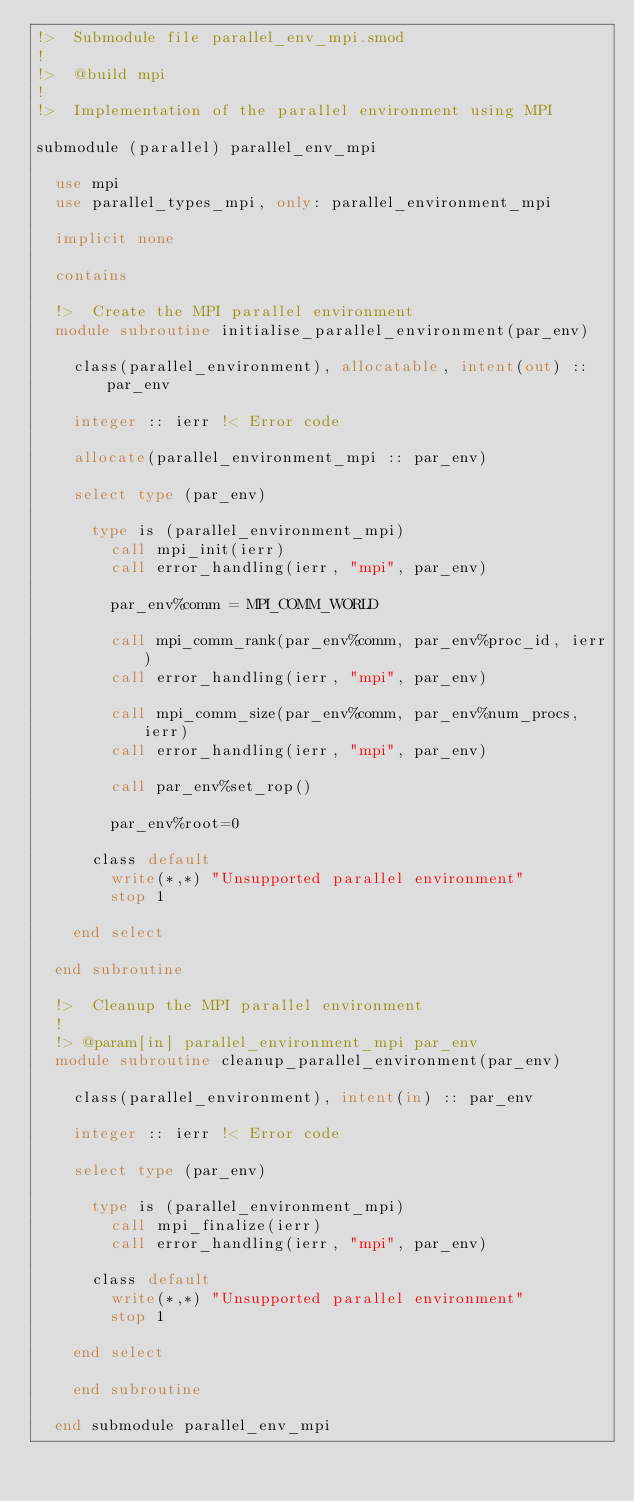Convert code to text. <code><loc_0><loc_0><loc_500><loc_500><_FORTRAN_>!>  Submodule file parallel_env_mpi.smod
!
!>  @build mpi
!
!>  Implementation of the parallel environment using MPI

submodule (parallel) parallel_env_mpi

  use mpi
  use parallel_types_mpi, only: parallel_environment_mpi

  implicit none

  contains

  !>  Create the MPI parallel environment
  module subroutine initialise_parallel_environment(par_env)

    class(parallel_environment), allocatable, intent(out) :: par_env

    integer :: ierr !< Error code

    allocate(parallel_environment_mpi :: par_env)

    select type (par_env)

      type is (parallel_environment_mpi)   
        call mpi_init(ierr)
        call error_handling(ierr, "mpi", par_env)

        par_env%comm = MPI_COMM_WORLD

        call mpi_comm_rank(par_env%comm, par_env%proc_id, ierr)
        call error_handling(ierr, "mpi", par_env)

        call mpi_comm_size(par_env%comm, par_env%num_procs, ierr)
        call error_handling(ierr, "mpi", par_env)

        call par_env%set_rop()
      
        par_env%root=0
    
      class default
        write(*,*) "Unsupported parallel environment"
        stop 1
    
    end select

  end subroutine

  !>  Cleanup the MPI parallel environment
  !
  !> @param[in] parallel_environment_mpi par_env
  module subroutine cleanup_parallel_environment(par_env)

    class(parallel_environment), intent(in) :: par_env
    
    integer :: ierr !< Error code

    select type (par_env)

      type is (parallel_environment_mpi)   
        call mpi_finalize(ierr)
        call error_handling(ierr, "mpi", par_env)
    
      class default
        write(*,*) "Unsupported parallel environment"
        stop 1
    
    end select

    end subroutine

  end submodule parallel_env_mpi
</code> 